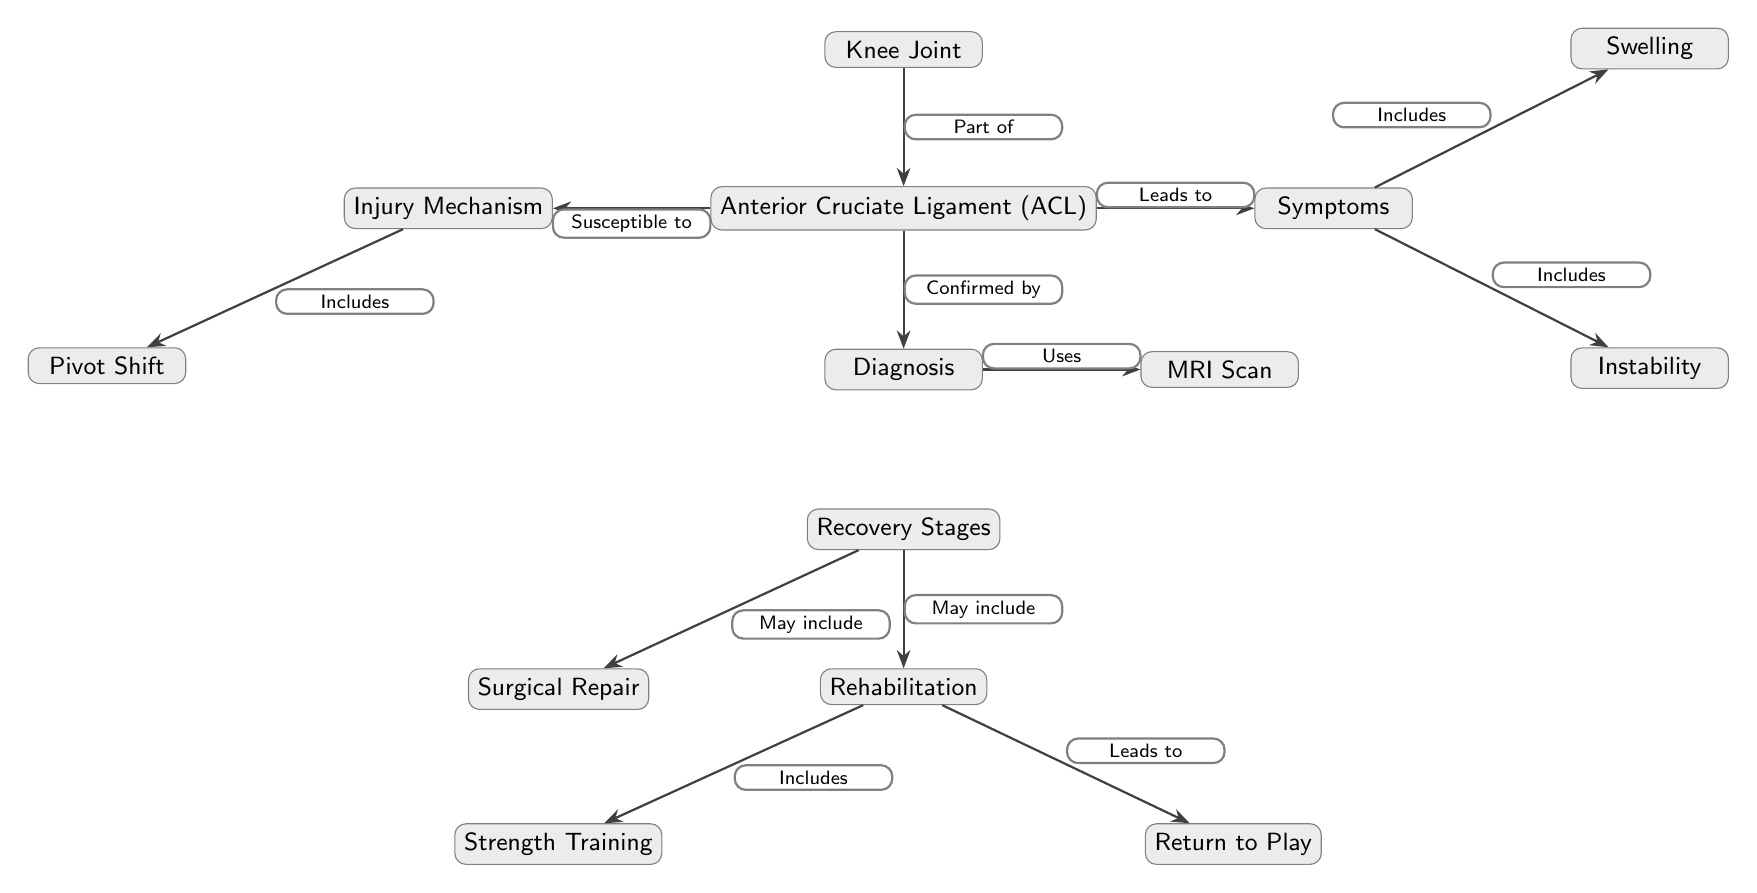What is the main ligament discussed in this diagram? The main ligament discussed in this diagram is labeled as "Anterior Cruciate Ligament (ACL)." This can be directly identified as it is positioned centrally in the diagram with the label attached.
Answer: Anterior Cruciate Ligament (ACL) What part of the body is the ACL associated with? The ACL is shown as a part of the "Knee Joint," which is situated above it in the diagram. The directional labeling "Part of" indicates its association to the knee joint.
Answer: Knee Joint What is one of the symptoms of an ACL injury? The diagram includes "Swelling" as one of the symptoms, which is positioned right of the ACL node under the symptoms node. The connecting edge indicates its relation to symptoms of an ACL injury.
Answer: Swelling Which diagnostic tool is mentioned in the recovery process? The "MRI Scan" is presented as part of the diagnosis process, and it is linked directly to the diagnosis node, indicating its use in confirming ACL injuries.
Answer: MRI Scan What does the recovery process include after surgery? The recovery process includes "Rehabilitation" after a possible surgical repair as depicted in the diagram where a connecting edge labeled "May include" indicates this relationship.
Answer: Rehabilitation How many symptoms are listed for an ACL injury? There are two symptoms listed: "Swelling" and "Instability." This can be determined by counting the symptoms nodes branching from the symptoms node in the diagram.
Answer: 2 What relationship does the ACL have with injury? The diagram states that the ACL is "Susceptible to" injury, evidenced by the direct edge linking ACL to its injury mechanism.
Answer: Susceptible to What leads to a return to play in footballers post-injury? "Strength Training" in the rehabilitation stage leads to "Return to Play." The diagram shows an edge that connects these two processes, indicating the progression needed for returning to the sport.
Answer: Strength Training What does the injury mechanism include? The "Injury Mechanism" includes "Pivot Shift," which is directly connected as a specific component leading to an ACL injury in the diagram.
Answer: Pivot Shift 